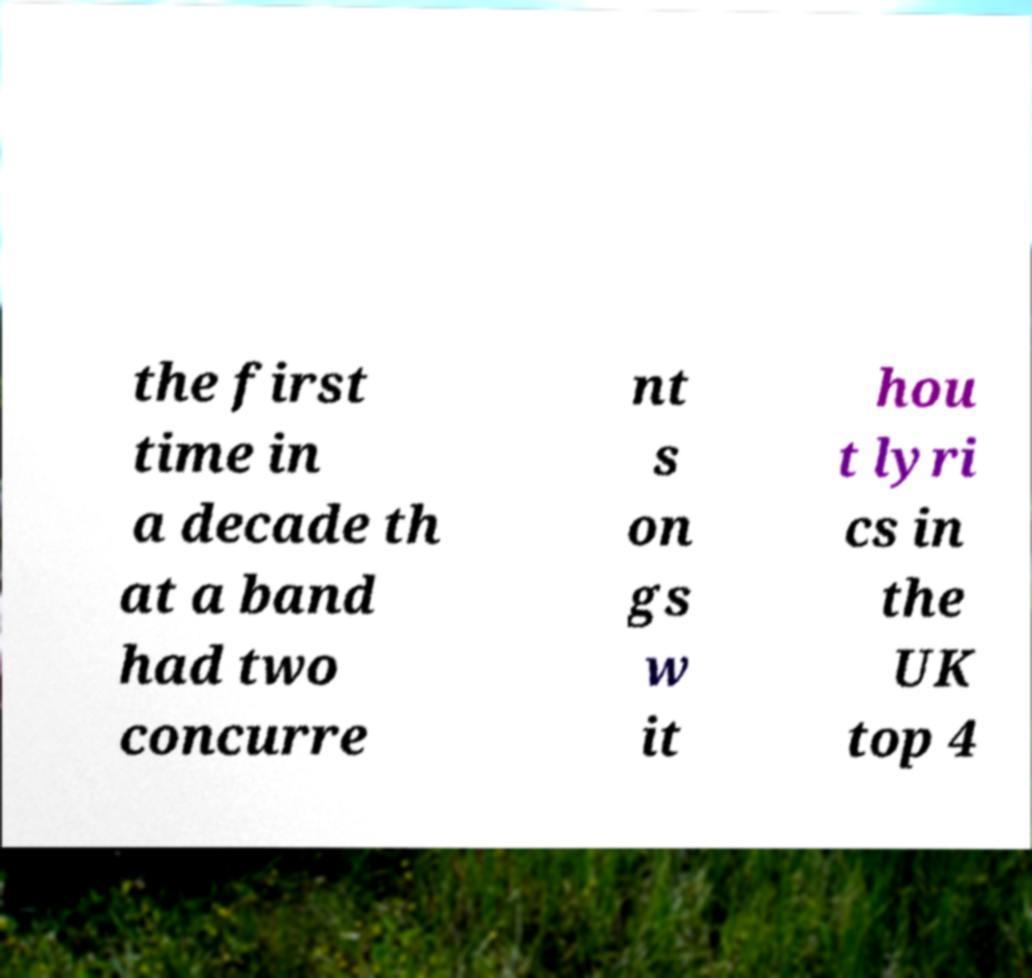Please read and relay the text visible in this image. What does it say? the first time in a decade th at a band had two concurre nt s on gs w it hou t lyri cs in the UK top 4 